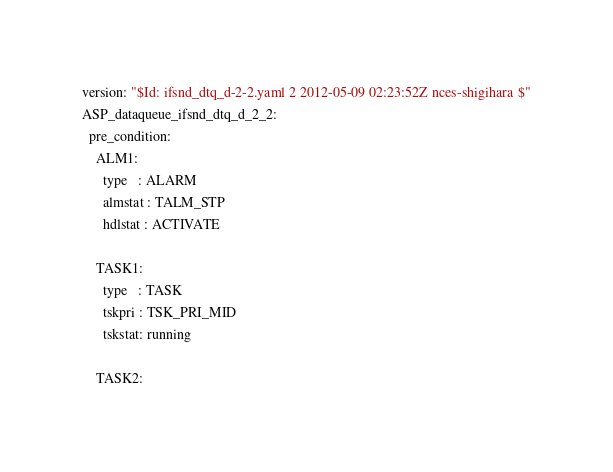<code> <loc_0><loc_0><loc_500><loc_500><_YAML_>version: "$Id: ifsnd_dtq_d-2-2.yaml 2 2012-05-09 02:23:52Z nces-shigihara $"
ASP_dataqueue_ifsnd_dtq_d_2_2:
  pre_condition:
    ALM1:
      type   : ALARM
      almstat : TALM_STP
      hdlstat : ACTIVATE

    TASK1:
      type   : TASK
      tskpri : TSK_PRI_MID
      tskstat: running

    TASK2:</code> 